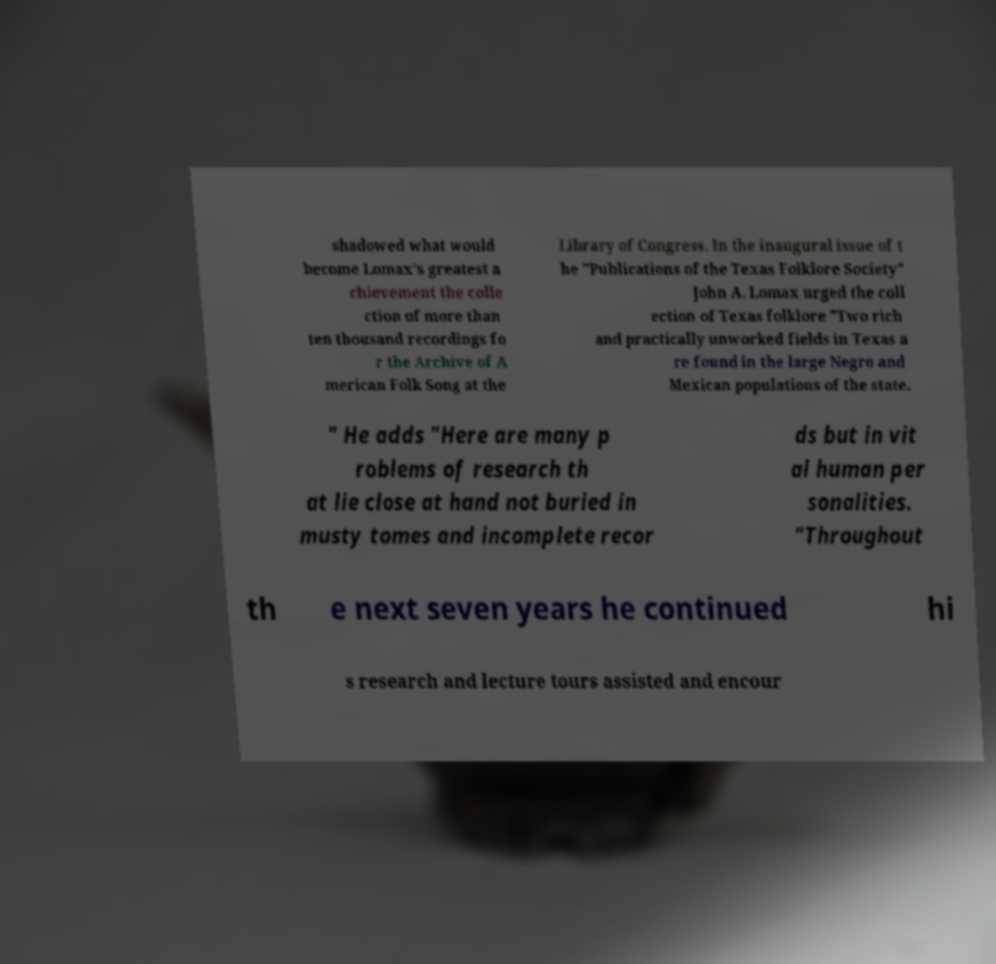Please read and relay the text visible in this image. What does it say? shadowed what would become Lomax's greatest a chievement the colle ction of more than ten thousand recordings fo r the Archive of A merican Folk Song at the Library of Congress. In the inaugural issue of t he "Publications of the Texas Folklore Society" John A. Lomax urged the coll ection of Texas folklore "Two rich and practically unworked fields in Texas a re found in the large Negro and Mexican populations of the state. " He adds "Here are many p roblems of research th at lie close at hand not buried in musty tomes and incomplete recor ds but in vit al human per sonalities. "Throughout th e next seven years he continued hi s research and lecture tours assisted and encour 